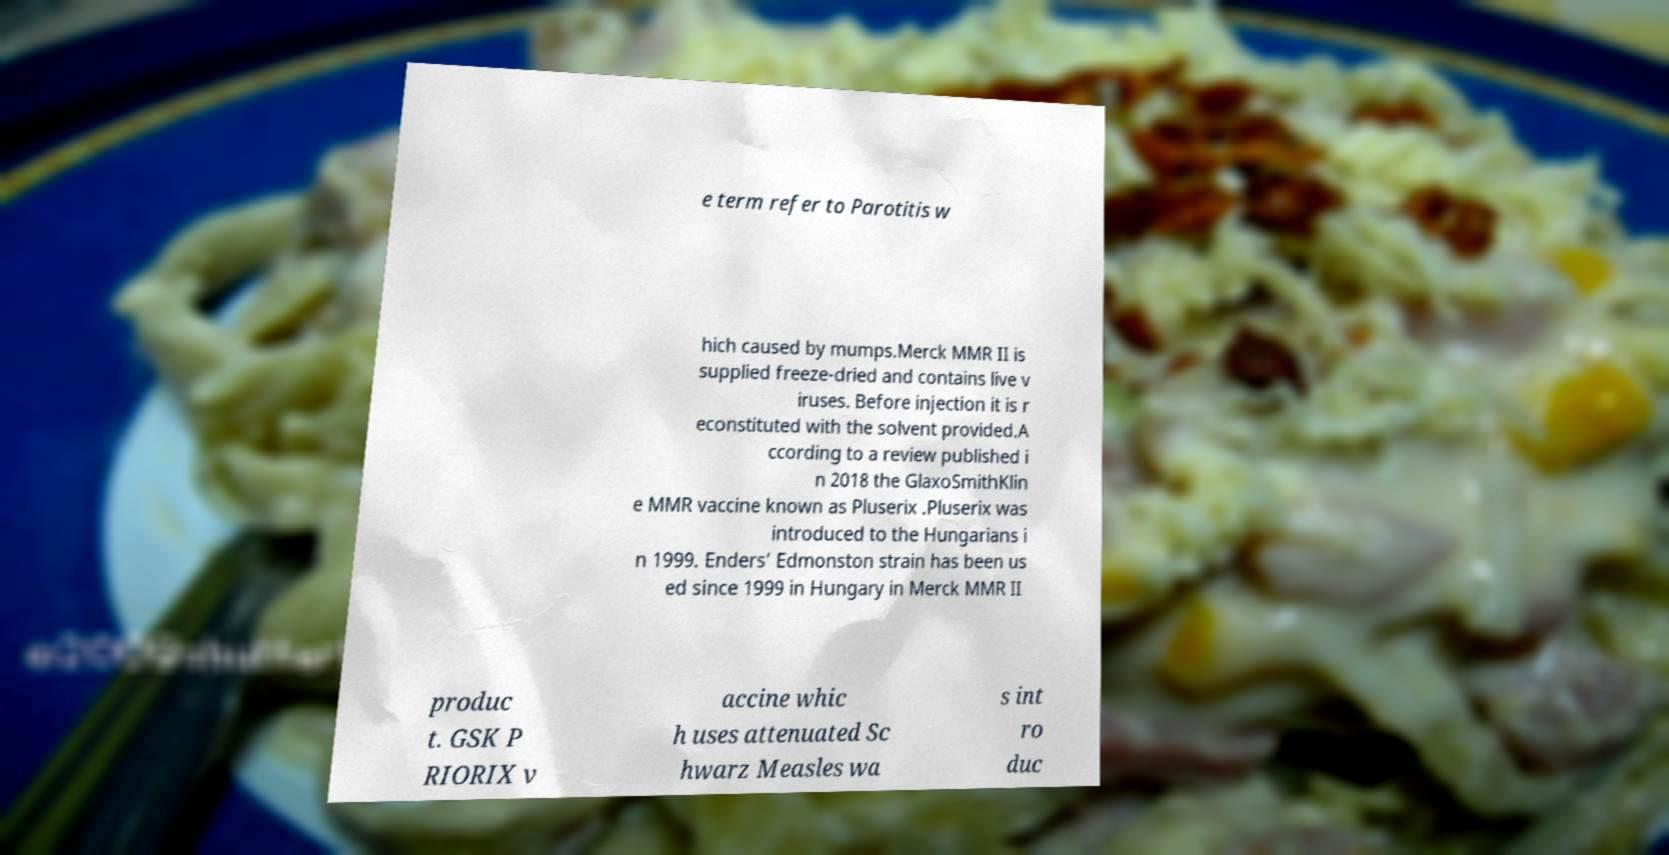Can you read and provide the text displayed in the image?This photo seems to have some interesting text. Can you extract and type it out for me? e term refer to Parotitis w hich caused by mumps.Merck MMR II is supplied freeze-dried and contains live v iruses. Before injection it is r econstituted with the solvent provided.A ccording to a review published i n 2018 the GlaxoSmithKlin e MMR vaccine known as Pluserix .Pluserix was introduced to the Hungarians i n 1999. Enders’ Edmonston strain has been us ed since 1999 in Hungary in Merck MMR II produc t. GSK P RIORIX v accine whic h uses attenuated Sc hwarz Measles wa s int ro duc 